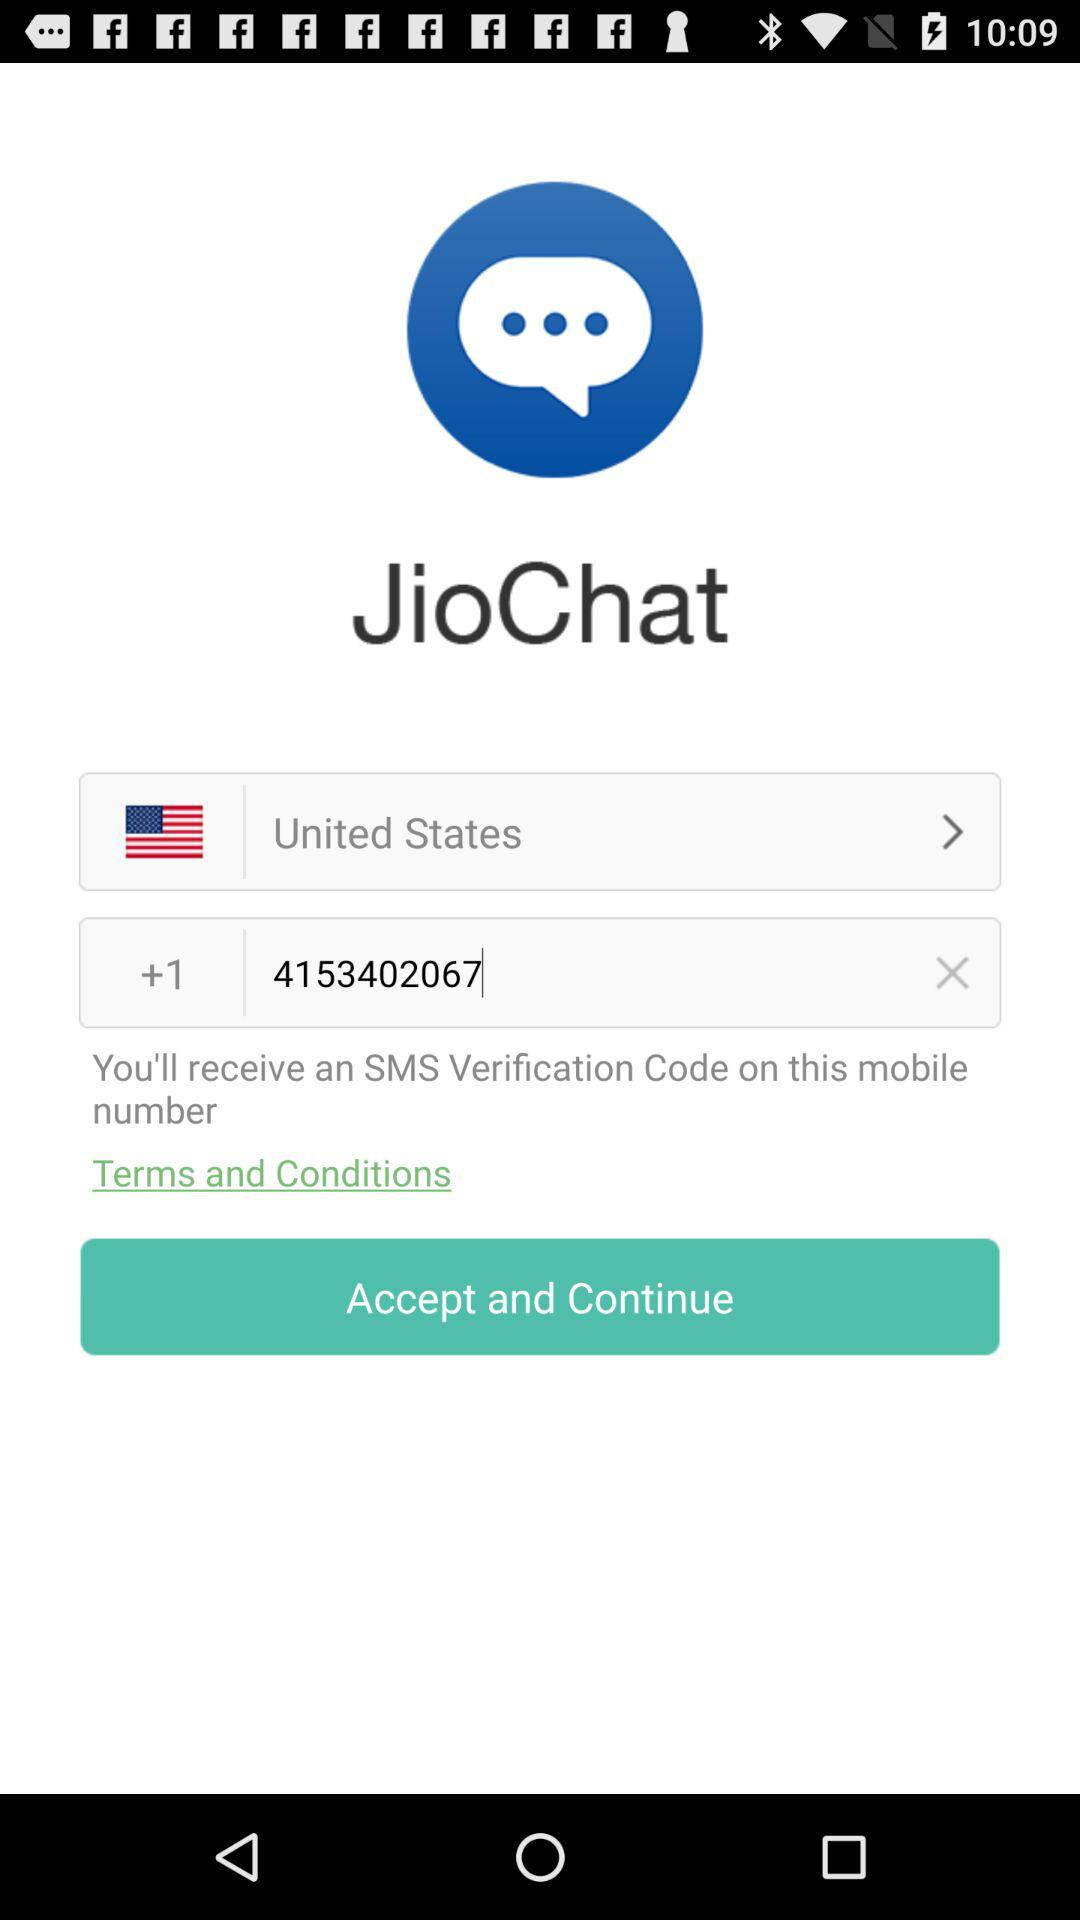What is the selected location? The selected location is the United States. 